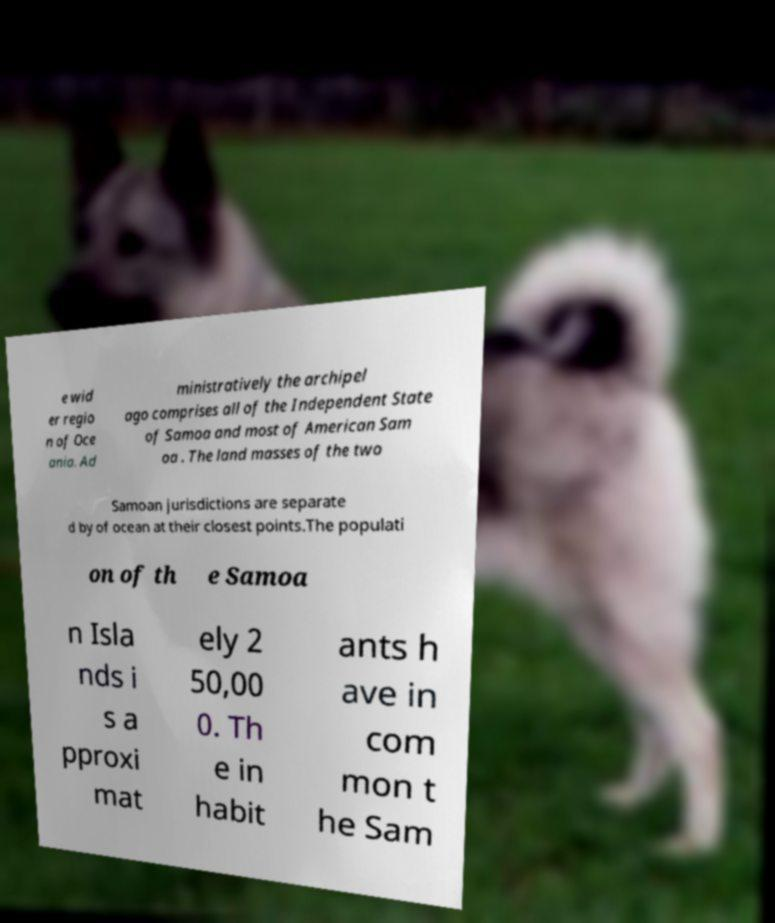Please identify and transcribe the text found in this image. e wid er regio n of Oce ania. Ad ministratively the archipel ago comprises all of the Independent State of Samoa and most of American Sam oa . The land masses of the two Samoan jurisdictions are separate d by of ocean at their closest points.The populati on of th e Samoa n Isla nds i s a pproxi mat ely 2 50,00 0. Th e in habit ants h ave in com mon t he Sam 